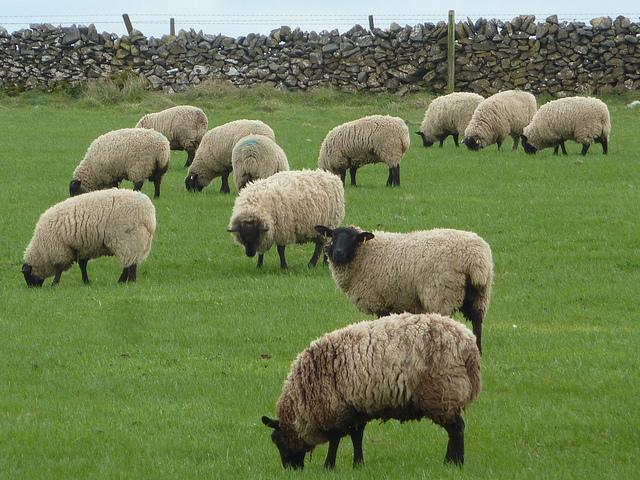How many sheep are looking up?
Give a very brief answer. 1. How many sheep are there?
Give a very brief answer. 12. 